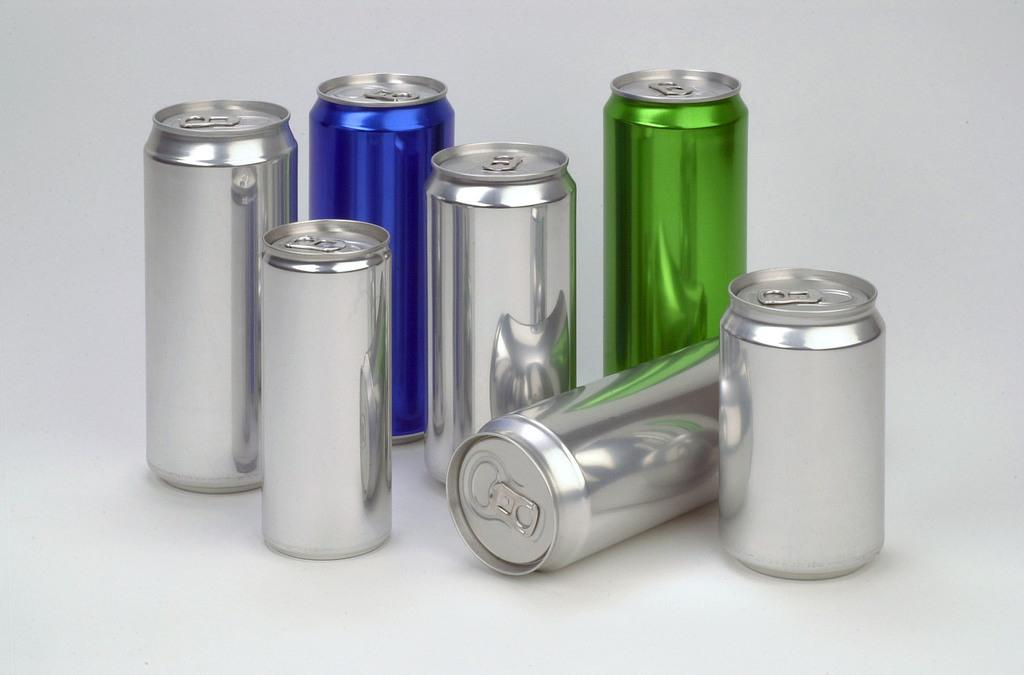How many coke bottles are visible in the image? There are seven coke bottles in the image. What colors are the coke bottles in the image? The coke bottles are in blue, green, and silver colors. What is the color of the background in the image? The background of the image is white. How much debt is represented by the cabbage in the image? There is no cabbage present in the image, so it is not possible to determine any debt associated with it. 